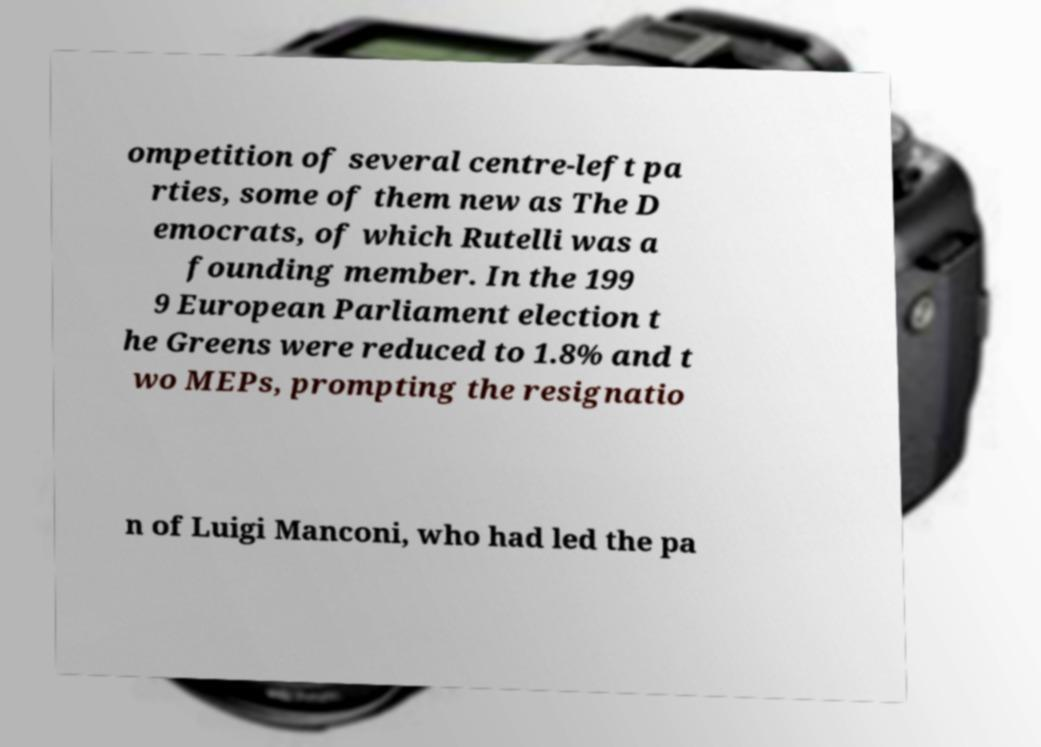There's text embedded in this image that I need extracted. Can you transcribe it verbatim? ompetition of several centre-left pa rties, some of them new as The D emocrats, of which Rutelli was a founding member. In the 199 9 European Parliament election t he Greens were reduced to 1.8% and t wo MEPs, prompting the resignatio n of Luigi Manconi, who had led the pa 